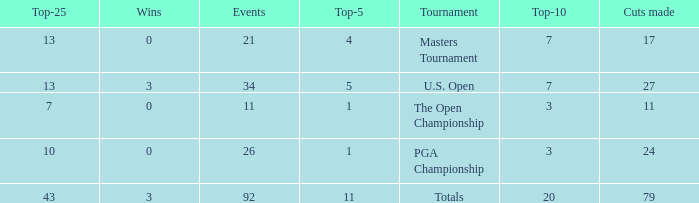Name the average cuts for top-25 more than 13 and top-5 less than 11 None. 